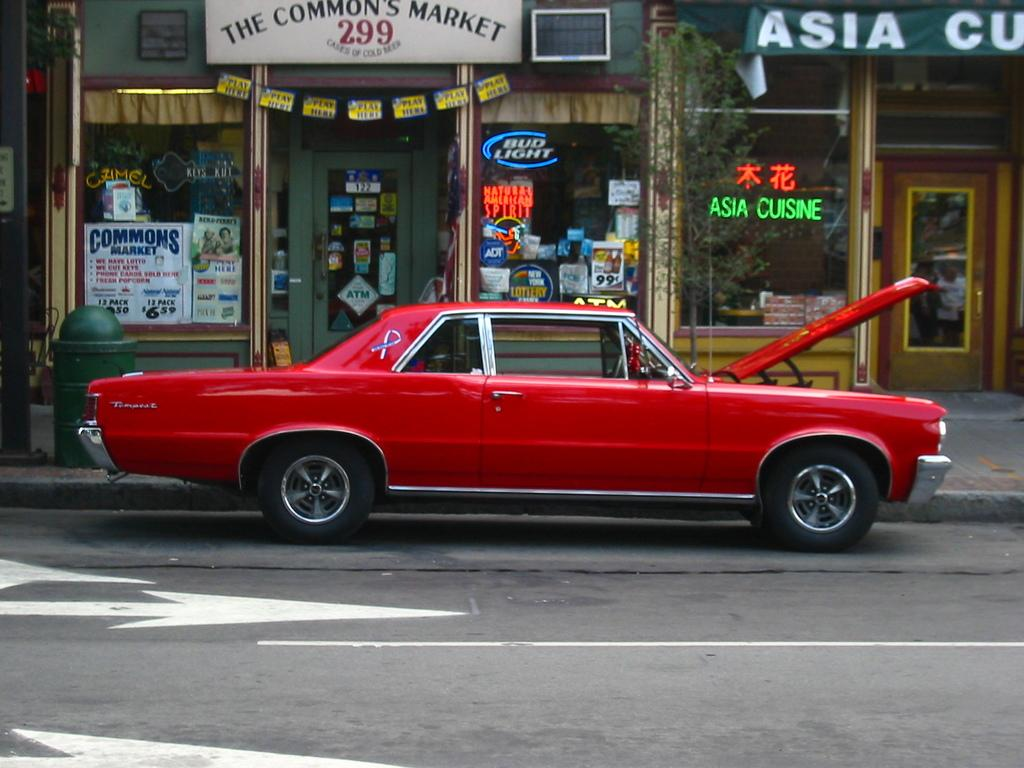<image>
Render a clear and concise summary of the photo. A parked red car with its hood up in front of an Asian restuarant. 